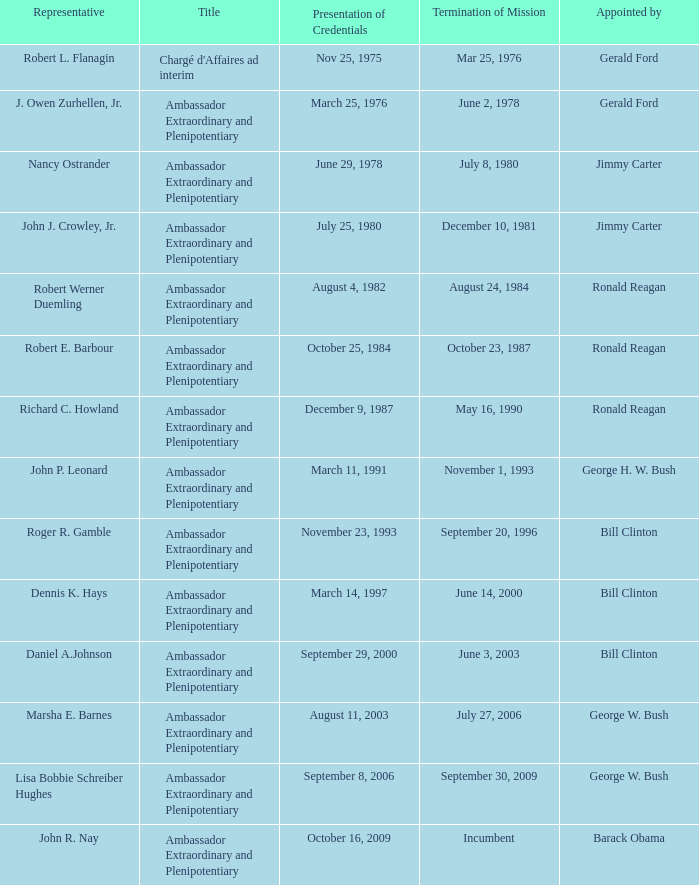What is the Termination of Mission date for Marsha E. Barnes, the Ambassador Extraordinary and Plenipotentiary? July 27, 2006. 